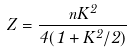<formula> <loc_0><loc_0><loc_500><loc_500>Z = \frac { n K ^ { 2 } } { 4 ( 1 + K ^ { 2 } / 2 ) }</formula> 